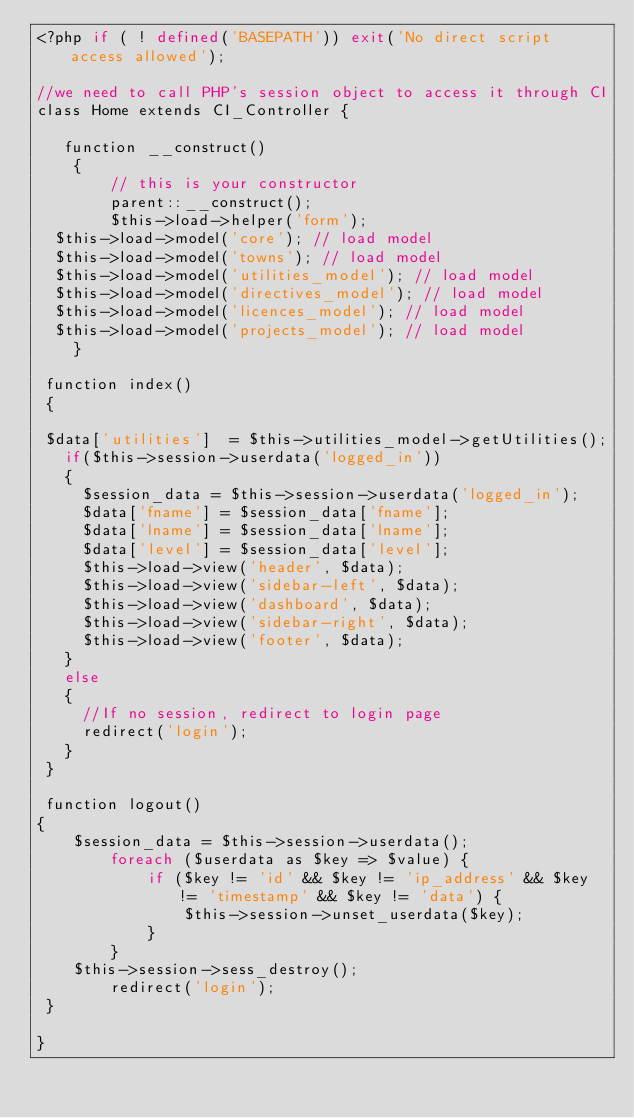Convert code to text. <code><loc_0><loc_0><loc_500><loc_500><_PHP_><?php if ( ! defined('BASEPATH')) exit('No direct script access allowed');

//we need to call PHP's session object to access it through CI
class Home extends CI_Controller {

   function __construct()
    {
        // this is your constructor
        parent::__construct();
        $this->load->helper('form');
	$this->load->model('core'); // load model
  $this->load->model('towns'); // load model
  $this->load->model('utilities_model'); // load model
  $this->load->model('directives_model'); // load model
  $this->load->model('licences_model'); // load model
  $this->load->model('projects_model'); // load model
    }

 function index()
 {

 $data['utilities']  = $this->utilities_model->getUtilities();
   if($this->session->userdata('logged_in'))
   {
     $session_data = $this->session->userdata('logged_in');
     $data['fname'] = $session_data['fname'];
     $data['lname'] = $session_data['lname'];
     $data['level'] = $session_data['level'];
     $this->load->view('header', $data);
     $this->load->view('sidebar-left', $data);
     $this->load->view('dashboard', $data);
     $this->load->view('sidebar-right', $data);
     $this->load->view('footer', $data);
   }
   else
   {
     //If no session, redirect to login page
     redirect('login');
   }
 }

 function logout()
{
    $session_data = $this->session->userdata();
        foreach ($userdata as $key => $value) {
            if ($key != 'id' && $key != 'ip_address' && $key != 'timestamp' && $key != 'data') {
                $this->session->unset_userdata($key);
            }
        }
    $this->session->sess_destroy();
        redirect('login');
 }

}</code> 